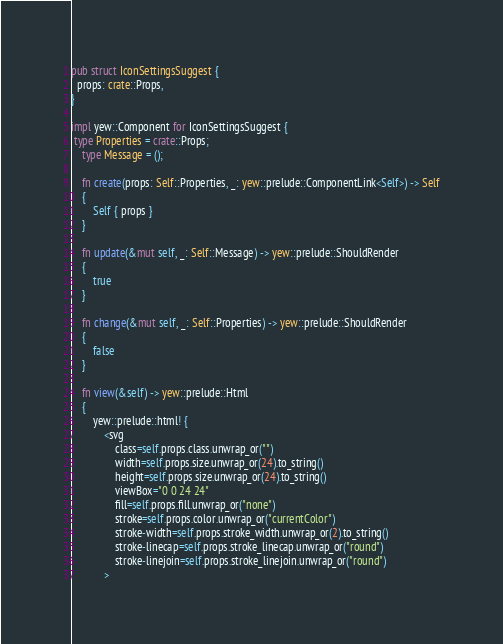<code> <loc_0><loc_0><loc_500><loc_500><_Rust_>
pub struct IconSettingsSuggest {
  props: crate::Props,
}

impl yew::Component for IconSettingsSuggest {
 type Properties = crate::Props;
    type Message = ();

    fn create(props: Self::Properties, _: yew::prelude::ComponentLink<Self>) -> Self
    {
        Self { props }
    }

    fn update(&mut self, _: Self::Message) -> yew::prelude::ShouldRender
    {
        true
    }

    fn change(&mut self, _: Self::Properties) -> yew::prelude::ShouldRender
    {
        false
    }

    fn view(&self) -> yew::prelude::Html
    {
        yew::prelude::html! {
            <svg
                class=self.props.class.unwrap_or("")
                width=self.props.size.unwrap_or(24).to_string()
                height=self.props.size.unwrap_or(24).to_string()
                viewBox="0 0 24 24"
                fill=self.props.fill.unwrap_or("none")
                stroke=self.props.color.unwrap_or("currentColor")
                stroke-width=self.props.stroke_width.unwrap_or(2).to_string()
                stroke-linecap=self.props.stroke_linecap.unwrap_or("round")
                stroke-linejoin=self.props.stroke_linejoin.unwrap_or("round")
            ></code> 